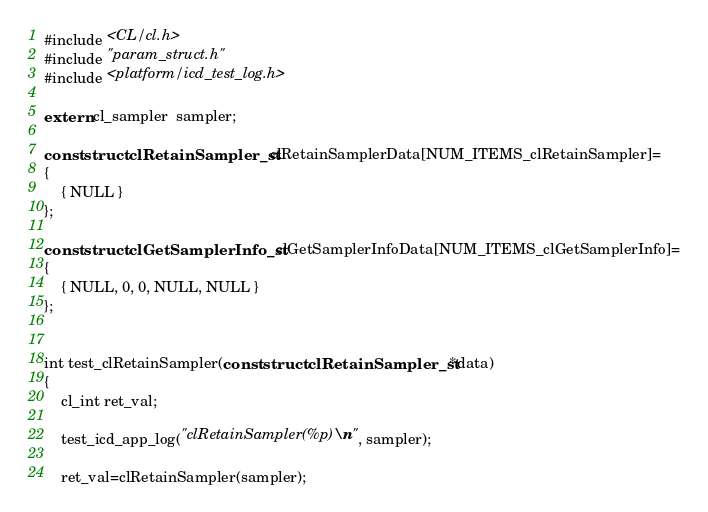<code> <loc_0><loc_0><loc_500><loc_500><_C_>#include <CL/cl.h>
#include "param_struct.h"
#include <platform/icd_test_log.h>

extern cl_sampler  sampler;

const struct clRetainSampler_st clRetainSamplerData[NUM_ITEMS_clRetainSampler]=
{
    { NULL }
};

const struct clGetSamplerInfo_st clGetSamplerInfoData[NUM_ITEMS_clGetSamplerInfo]=
{
    { NULL, 0, 0, NULL, NULL }
};


int test_clRetainSampler(const struct clRetainSampler_st *data)
{
    cl_int ret_val;

    test_icd_app_log("clRetainSampler(%p)\n", sampler);

    ret_val=clRetainSampler(sampler);
</code> 